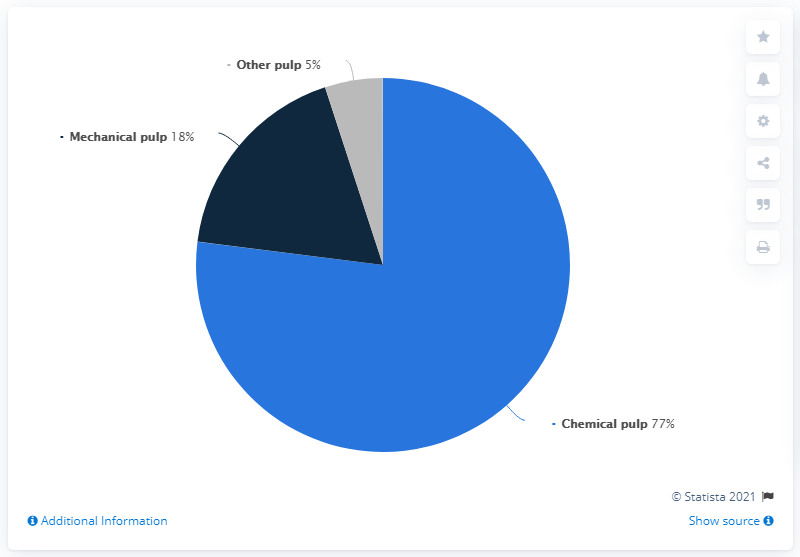List a handful of essential elements in this visual. The smallest color segment is gray. The results of the two smallest pulp production measurements indicate that the average percent of these measurements is 11.5%. 